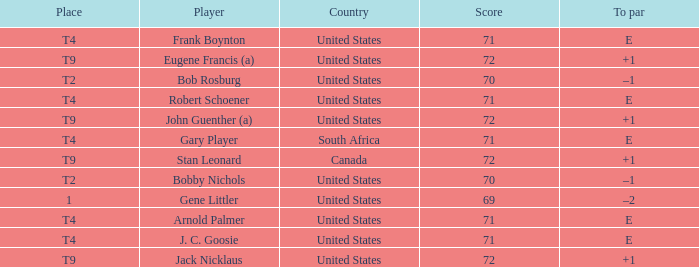What is To Par, when Country is "United States", when Place is "T4", and when Player is "Arnold Palmer"? E. 